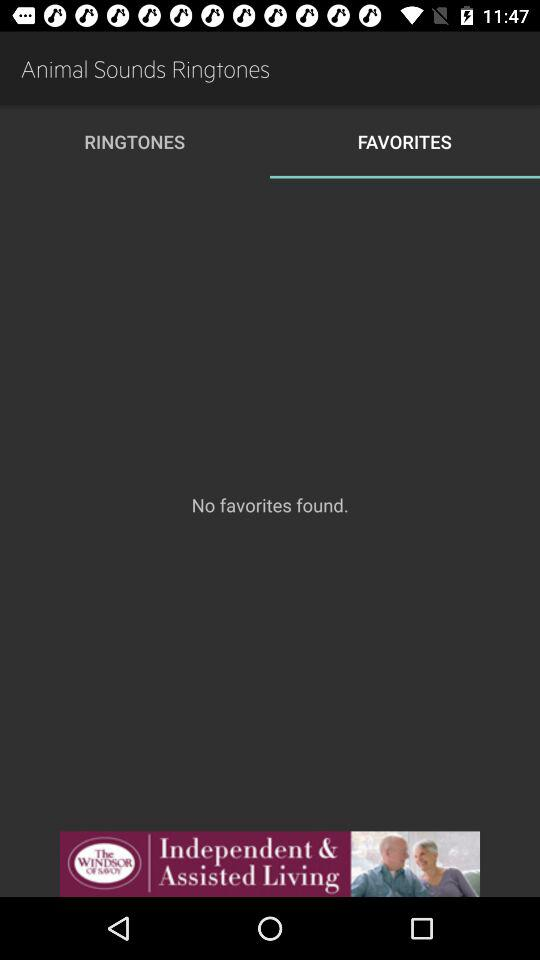Which tab is selected? The selected tab is "FAVORITES". 